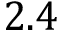Convert formula to latex. <formula><loc_0><loc_0><loc_500><loc_500>2 . 4</formula> 